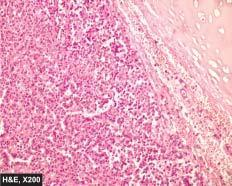what are these nests composed of?
Answer the question using a single word or phrase. Uniform cuboidal cells having granular cytoplasm 